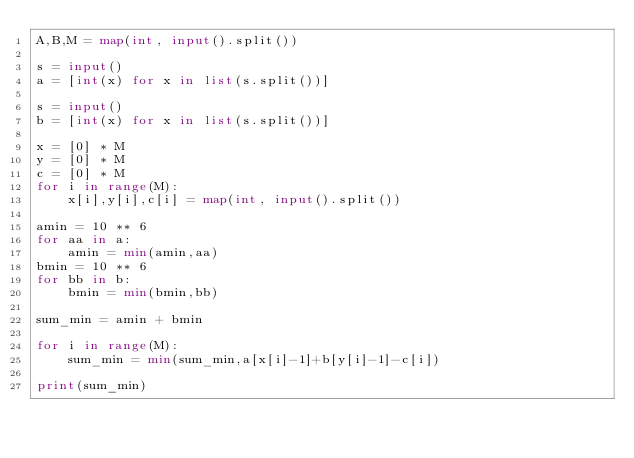Convert code to text. <code><loc_0><loc_0><loc_500><loc_500><_Python_>A,B,M = map(int, input().split())

s = input()
a = [int(x) for x in list(s.split())]

s = input()
b = [int(x) for x in list(s.split())]

x = [0] * M
y = [0] * M
c = [0] * M
for i in range(M):
    x[i],y[i],c[i] = map(int, input().split())

amin = 10 ** 6
for aa in a:
    amin = min(amin,aa)
bmin = 10 ** 6
for bb in b:
    bmin = min(bmin,bb)

sum_min = amin + bmin

for i in range(M):
    sum_min = min(sum_min,a[x[i]-1]+b[y[i]-1]-c[i])

print(sum_min)
</code> 